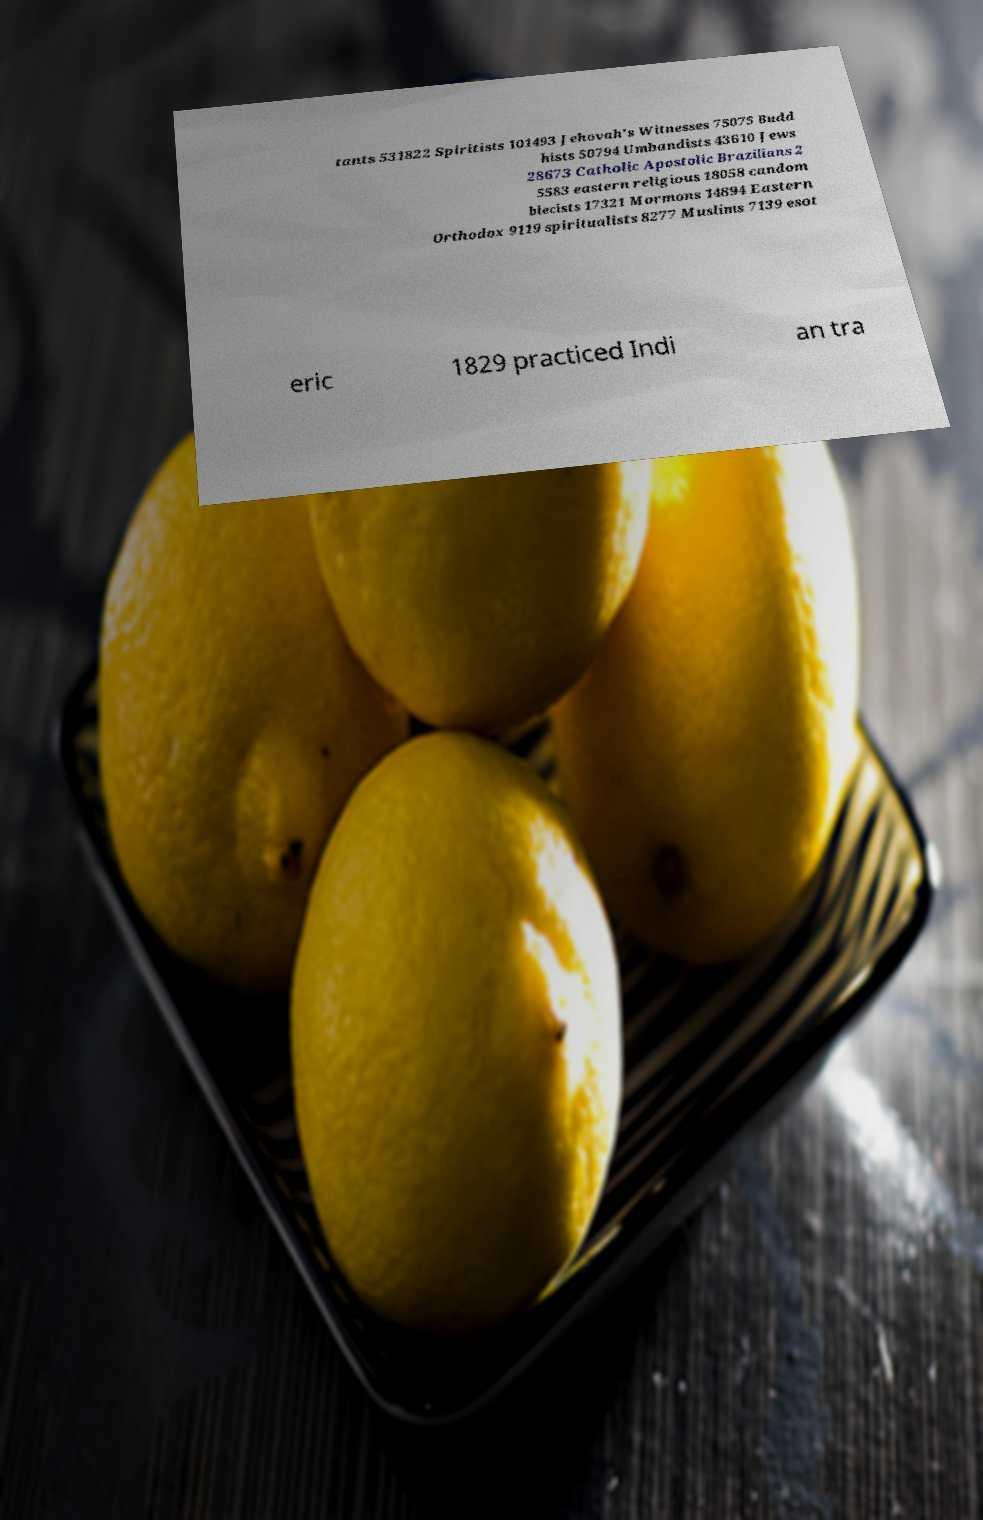There's text embedded in this image that I need extracted. Can you transcribe it verbatim? tants 531822 Spiritists 101493 Jehovah's Witnesses 75075 Budd hists 50794 Umbandists 43610 Jews 28673 Catholic Apostolic Brazilians 2 5583 eastern religious 18058 candom blecists 17321 Mormons 14894 Eastern Orthodox 9119 spiritualists 8277 Muslims 7139 esot eric 1829 practiced Indi an tra 